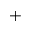Convert formula to latex. <formula><loc_0><loc_0><loc_500><loc_500>^ { + }</formula> 